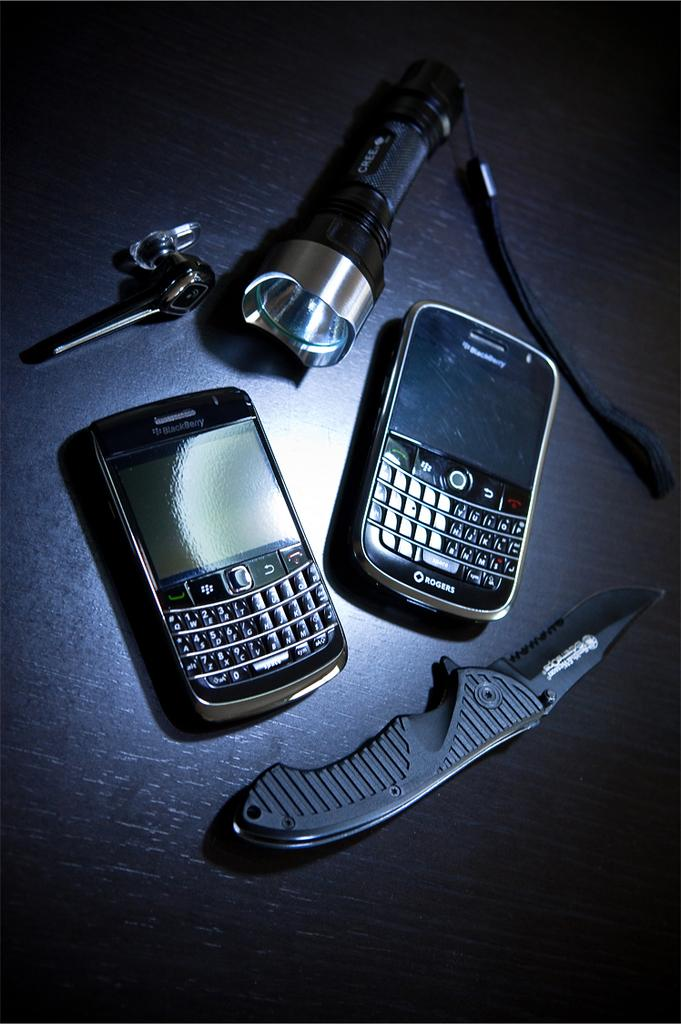What type of electronic devices can be seen in the image? There are mobile phones in the image. What other objects are present in the image? There is a knife, a torch, and a key in the image. On what surface are these objects placed? The objects are placed on a surface. How many sisters are holding the mobile phones in the image? There are no sisters present in the image, and the mobile phones are not being held by anyone. 